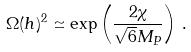Convert formula to latex. <formula><loc_0><loc_0><loc_500><loc_500>\Omega ( h ) ^ { 2 } \simeq \exp \left ( \frac { 2 \chi } { \sqrt { 6 } M _ { P } } \right ) \, .</formula> 